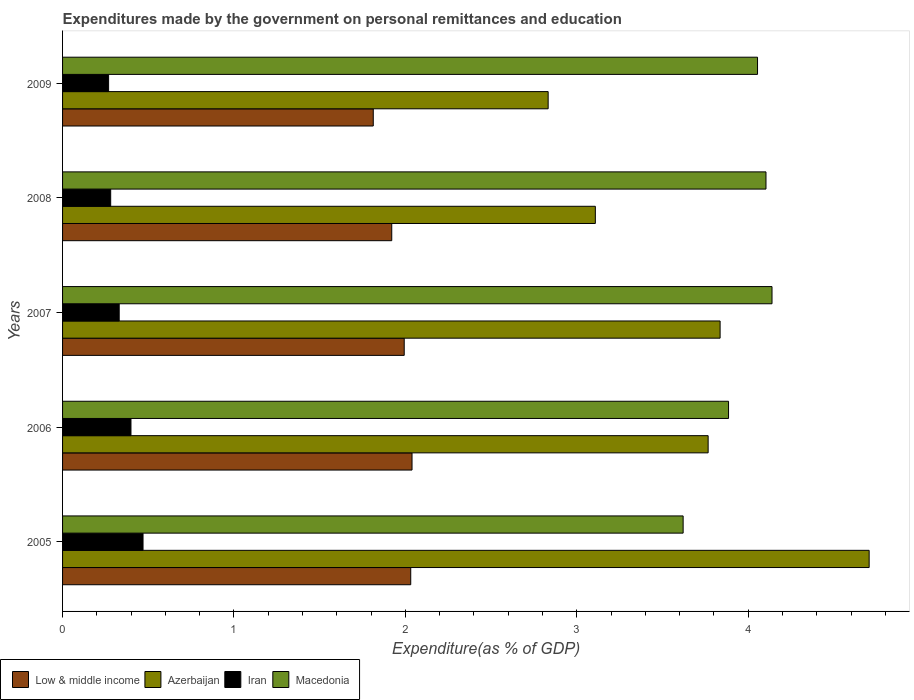How many different coloured bars are there?
Ensure brevity in your answer.  4. Are the number of bars per tick equal to the number of legend labels?
Provide a succinct answer. Yes. How many bars are there on the 5th tick from the top?
Your answer should be very brief. 4. How many bars are there on the 5th tick from the bottom?
Offer a terse response. 4. What is the label of the 3rd group of bars from the top?
Your response must be concise. 2007. What is the expenditures made by the government on personal remittances and education in Low & middle income in 2005?
Ensure brevity in your answer.  2.03. Across all years, what is the maximum expenditures made by the government on personal remittances and education in Iran?
Your response must be concise. 0.47. Across all years, what is the minimum expenditures made by the government on personal remittances and education in Low & middle income?
Ensure brevity in your answer.  1.81. What is the total expenditures made by the government on personal remittances and education in Iran in the graph?
Keep it short and to the point. 1.75. What is the difference between the expenditures made by the government on personal remittances and education in Low & middle income in 2006 and that in 2007?
Keep it short and to the point. 0.05. What is the difference between the expenditures made by the government on personal remittances and education in Low & middle income in 2006 and the expenditures made by the government on personal remittances and education in Iran in 2005?
Your answer should be very brief. 1.57. What is the average expenditures made by the government on personal remittances and education in Low & middle income per year?
Offer a terse response. 1.96. In the year 2007, what is the difference between the expenditures made by the government on personal remittances and education in Iran and expenditures made by the government on personal remittances and education in Azerbaijan?
Ensure brevity in your answer.  -3.51. What is the ratio of the expenditures made by the government on personal remittances and education in Low & middle income in 2006 to that in 2008?
Offer a terse response. 1.06. Is the expenditures made by the government on personal remittances and education in Low & middle income in 2005 less than that in 2006?
Ensure brevity in your answer.  Yes. Is the difference between the expenditures made by the government on personal remittances and education in Iran in 2006 and 2007 greater than the difference between the expenditures made by the government on personal remittances and education in Azerbaijan in 2006 and 2007?
Give a very brief answer. Yes. What is the difference between the highest and the second highest expenditures made by the government on personal remittances and education in Low & middle income?
Give a very brief answer. 0.01. What is the difference between the highest and the lowest expenditures made by the government on personal remittances and education in Azerbaijan?
Provide a short and direct response. 1.87. Is it the case that in every year, the sum of the expenditures made by the government on personal remittances and education in Macedonia and expenditures made by the government on personal remittances and education in Low & middle income is greater than the sum of expenditures made by the government on personal remittances and education in Iran and expenditures made by the government on personal remittances and education in Azerbaijan?
Give a very brief answer. No. What does the 2nd bar from the top in 2008 represents?
Offer a terse response. Iran. What does the 2nd bar from the bottom in 2009 represents?
Offer a very short reply. Azerbaijan. Is it the case that in every year, the sum of the expenditures made by the government on personal remittances and education in Low & middle income and expenditures made by the government on personal remittances and education in Macedonia is greater than the expenditures made by the government on personal remittances and education in Iran?
Your response must be concise. Yes. How many bars are there?
Offer a terse response. 20. Are all the bars in the graph horizontal?
Your response must be concise. Yes. How many years are there in the graph?
Provide a succinct answer. 5. Does the graph contain any zero values?
Offer a very short reply. No. Where does the legend appear in the graph?
Offer a very short reply. Bottom left. How many legend labels are there?
Offer a very short reply. 4. What is the title of the graph?
Offer a very short reply. Expenditures made by the government on personal remittances and education. Does "Kuwait" appear as one of the legend labels in the graph?
Your answer should be very brief. No. What is the label or title of the X-axis?
Keep it short and to the point. Expenditure(as % of GDP). What is the label or title of the Y-axis?
Keep it short and to the point. Years. What is the Expenditure(as % of GDP) in Low & middle income in 2005?
Offer a very short reply. 2.03. What is the Expenditure(as % of GDP) of Azerbaijan in 2005?
Your response must be concise. 4.71. What is the Expenditure(as % of GDP) of Iran in 2005?
Keep it short and to the point. 0.47. What is the Expenditure(as % of GDP) of Macedonia in 2005?
Make the answer very short. 3.62. What is the Expenditure(as % of GDP) in Low & middle income in 2006?
Make the answer very short. 2.04. What is the Expenditure(as % of GDP) of Azerbaijan in 2006?
Provide a short and direct response. 3.77. What is the Expenditure(as % of GDP) in Iran in 2006?
Offer a very short reply. 0.4. What is the Expenditure(as % of GDP) of Macedonia in 2006?
Make the answer very short. 3.88. What is the Expenditure(as % of GDP) of Low & middle income in 2007?
Your answer should be compact. 1.99. What is the Expenditure(as % of GDP) in Azerbaijan in 2007?
Offer a very short reply. 3.84. What is the Expenditure(as % of GDP) in Iran in 2007?
Give a very brief answer. 0.33. What is the Expenditure(as % of GDP) in Macedonia in 2007?
Offer a terse response. 4.14. What is the Expenditure(as % of GDP) in Low & middle income in 2008?
Your answer should be very brief. 1.92. What is the Expenditure(as % of GDP) of Azerbaijan in 2008?
Offer a terse response. 3.11. What is the Expenditure(as % of GDP) of Iran in 2008?
Your answer should be compact. 0.28. What is the Expenditure(as % of GDP) of Macedonia in 2008?
Offer a very short reply. 4.1. What is the Expenditure(as % of GDP) in Low & middle income in 2009?
Provide a short and direct response. 1.81. What is the Expenditure(as % of GDP) of Azerbaijan in 2009?
Provide a succinct answer. 2.83. What is the Expenditure(as % of GDP) in Iran in 2009?
Ensure brevity in your answer.  0.27. What is the Expenditure(as % of GDP) in Macedonia in 2009?
Your answer should be compact. 4.05. Across all years, what is the maximum Expenditure(as % of GDP) in Low & middle income?
Your answer should be compact. 2.04. Across all years, what is the maximum Expenditure(as % of GDP) of Azerbaijan?
Your response must be concise. 4.71. Across all years, what is the maximum Expenditure(as % of GDP) of Iran?
Your response must be concise. 0.47. Across all years, what is the maximum Expenditure(as % of GDP) in Macedonia?
Make the answer very short. 4.14. Across all years, what is the minimum Expenditure(as % of GDP) in Low & middle income?
Offer a very short reply. 1.81. Across all years, what is the minimum Expenditure(as % of GDP) of Azerbaijan?
Ensure brevity in your answer.  2.83. Across all years, what is the minimum Expenditure(as % of GDP) in Iran?
Provide a succinct answer. 0.27. Across all years, what is the minimum Expenditure(as % of GDP) in Macedonia?
Offer a terse response. 3.62. What is the total Expenditure(as % of GDP) of Low & middle income in the graph?
Give a very brief answer. 9.8. What is the total Expenditure(as % of GDP) in Azerbaijan in the graph?
Provide a short and direct response. 18.25. What is the total Expenditure(as % of GDP) of Iran in the graph?
Your response must be concise. 1.75. What is the total Expenditure(as % of GDP) in Macedonia in the graph?
Your answer should be very brief. 19.8. What is the difference between the Expenditure(as % of GDP) of Low & middle income in 2005 and that in 2006?
Keep it short and to the point. -0.01. What is the difference between the Expenditure(as % of GDP) in Azerbaijan in 2005 and that in 2006?
Offer a very short reply. 0.94. What is the difference between the Expenditure(as % of GDP) of Iran in 2005 and that in 2006?
Your answer should be very brief. 0.07. What is the difference between the Expenditure(as % of GDP) of Macedonia in 2005 and that in 2006?
Provide a succinct answer. -0.26. What is the difference between the Expenditure(as % of GDP) of Low & middle income in 2005 and that in 2007?
Give a very brief answer. 0.04. What is the difference between the Expenditure(as % of GDP) of Azerbaijan in 2005 and that in 2007?
Your answer should be compact. 0.87. What is the difference between the Expenditure(as % of GDP) in Iran in 2005 and that in 2007?
Your response must be concise. 0.14. What is the difference between the Expenditure(as % of GDP) of Macedonia in 2005 and that in 2007?
Keep it short and to the point. -0.52. What is the difference between the Expenditure(as % of GDP) in Low & middle income in 2005 and that in 2008?
Your response must be concise. 0.11. What is the difference between the Expenditure(as % of GDP) in Azerbaijan in 2005 and that in 2008?
Offer a very short reply. 1.6. What is the difference between the Expenditure(as % of GDP) in Iran in 2005 and that in 2008?
Give a very brief answer. 0.19. What is the difference between the Expenditure(as % of GDP) of Macedonia in 2005 and that in 2008?
Your answer should be very brief. -0.48. What is the difference between the Expenditure(as % of GDP) in Low & middle income in 2005 and that in 2009?
Keep it short and to the point. 0.22. What is the difference between the Expenditure(as % of GDP) of Azerbaijan in 2005 and that in 2009?
Keep it short and to the point. 1.87. What is the difference between the Expenditure(as % of GDP) of Iran in 2005 and that in 2009?
Keep it short and to the point. 0.2. What is the difference between the Expenditure(as % of GDP) of Macedonia in 2005 and that in 2009?
Ensure brevity in your answer.  -0.43. What is the difference between the Expenditure(as % of GDP) of Low & middle income in 2006 and that in 2007?
Ensure brevity in your answer.  0.05. What is the difference between the Expenditure(as % of GDP) in Azerbaijan in 2006 and that in 2007?
Provide a short and direct response. -0.07. What is the difference between the Expenditure(as % of GDP) in Iran in 2006 and that in 2007?
Your answer should be compact. 0.07. What is the difference between the Expenditure(as % of GDP) in Macedonia in 2006 and that in 2007?
Offer a very short reply. -0.25. What is the difference between the Expenditure(as % of GDP) of Low & middle income in 2006 and that in 2008?
Your answer should be compact. 0.12. What is the difference between the Expenditure(as % of GDP) of Azerbaijan in 2006 and that in 2008?
Provide a short and direct response. 0.66. What is the difference between the Expenditure(as % of GDP) in Iran in 2006 and that in 2008?
Give a very brief answer. 0.12. What is the difference between the Expenditure(as % of GDP) in Macedonia in 2006 and that in 2008?
Provide a succinct answer. -0.22. What is the difference between the Expenditure(as % of GDP) in Low & middle income in 2006 and that in 2009?
Give a very brief answer. 0.23. What is the difference between the Expenditure(as % of GDP) of Azerbaijan in 2006 and that in 2009?
Make the answer very short. 0.93. What is the difference between the Expenditure(as % of GDP) in Iran in 2006 and that in 2009?
Your answer should be very brief. 0.13. What is the difference between the Expenditure(as % of GDP) in Macedonia in 2006 and that in 2009?
Your answer should be very brief. -0.17. What is the difference between the Expenditure(as % of GDP) in Low & middle income in 2007 and that in 2008?
Keep it short and to the point. 0.07. What is the difference between the Expenditure(as % of GDP) of Azerbaijan in 2007 and that in 2008?
Offer a terse response. 0.73. What is the difference between the Expenditure(as % of GDP) of Iran in 2007 and that in 2008?
Your answer should be very brief. 0.05. What is the difference between the Expenditure(as % of GDP) of Macedonia in 2007 and that in 2008?
Your answer should be very brief. 0.04. What is the difference between the Expenditure(as % of GDP) of Low & middle income in 2007 and that in 2009?
Your answer should be very brief. 0.18. What is the difference between the Expenditure(as % of GDP) of Iran in 2007 and that in 2009?
Provide a succinct answer. 0.06. What is the difference between the Expenditure(as % of GDP) in Macedonia in 2007 and that in 2009?
Provide a succinct answer. 0.08. What is the difference between the Expenditure(as % of GDP) of Low & middle income in 2008 and that in 2009?
Your answer should be very brief. 0.11. What is the difference between the Expenditure(as % of GDP) in Azerbaijan in 2008 and that in 2009?
Your answer should be compact. 0.28. What is the difference between the Expenditure(as % of GDP) in Iran in 2008 and that in 2009?
Offer a very short reply. 0.01. What is the difference between the Expenditure(as % of GDP) in Macedonia in 2008 and that in 2009?
Keep it short and to the point. 0.05. What is the difference between the Expenditure(as % of GDP) in Low & middle income in 2005 and the Expenditure(as % of GDP) in Azerbaijan in 2006?
Offer a very short reply. -1.73. What is the difference between the Expenditure(as % of GDP) in Low & middle income in 2005 and the Expenditure(as % of GDP) in Iran in 2006?
Keep it short and to the point. 1.63. What is the difference between the Expenditure(as % of GDP) in Low & middle income in 2005 and the Expenditure(as % of GDP) in Macedonia in 2006?
Provide a short and direct response. -1.85. What is the difference between the Expenditure(as % of GDP) in Azerbaijan in 2005 and the Expenditure(as % of GDP) in Iran in 2006?
Offer a terse response. 4.31. What is the difference between the Expenditure(as % of GDP) in Azerbaijan in 2005 and the Expenditure(as % of GDP) in Macedonia in 2006?
Provide a succinct answer. 0.82. What is the difference between the Expenditure(as % of GDP) in Iran in 2005 and the Expenditure(as % of GDP) in Macedonia in 2006?
Offer a terse response. -3.42. What is the difference between the Expenditure(as % of GDP) in Low & middle income in 2005 and the Expenditure(as % of GDP) in Azerbaijan in 2007?
Keep it short and to the point. -1.8. What is the difference between the Expenditure(as % of GDP) of Low & middle income in 2005 and the Expenditure(as % of GDP) of Iran in 2007?
Give a very brief answer. 1.7. What is the difference between the Expenditure(as % of GDP) of Low & middle income in 2005 and the Expenditure(as % of GDP) of Macedonia in 2007?
Offer a very short reply. -2.11. What is the difference between the Expenditure(as % of GDP) in Azerbaijan in 2005 and the Expenditure(as % of GDP) in Iran in 2007?
Ensure brevity in your answer.  4.37. What is the difference between the Expenditure(as % of GDP) of Azerbaijan in 2005 and the Expenditure(as % of GDP) of Macedonia in 2007?
Keep it short and to the point. 0.57. What is the difference between the Expenditure(as % of GDP) of Iran in 2005 and the Expenditure(as % of GDP) of Macedonia in 2007?
Your response must be concise. -3.67. What is the difference between the Expenditure(as % of GDP) of Low & middle income in 2005 and the Expenditure(as % of GDP) of Azerbaijan in 2008?
Offer a terse response. -1.08. What is the difference between the Expenditure(as % of GDP) of Low & middle income in 2005 and the Expenditure(as % of GDP) of Iran in 2008?
Provide a short and direct response. 1.75. What is the difference between the Expenditure(as % of GDP) of Low & middle income in 2005 and the Expenditure(as % of GDP) of Macedonia in 2008?
Make the answer very short. -2.07. What is the difference between the Expenditure(as % of GDP) of Azerbaijan in 2005 and the Expenditure(as % of GDP) of Iran in 2008?
Give a very brief answer. 4.42. What is the difference between the Expenditure(as % of GDP) in Azerbaijan in 2005 and the Expenditure(as % of GDP) in Macedonia in 2008?
Your answer should be compact. 0.6. What is the difference between the Expenditure(as % of GDP) in Iran in 2005 and the Expenditure(as % of GDP) in Macedonia in 2008?
Make the answer very short. -3.63. What is the difference between the Expenditure(as % of GDP) of Low & middle income in 2005 and the Expenditure(as % of GDP) of Azerbaijan in 2009?
Provide a succinct answer. -0.8. What is the difference between the Expenditure(as % of GDP) in Low & middle income in 2005 and the Expenditure(as % of GDP) in Iran in 2009?
Offer a very short reply. 1.76. What is the difference between the Expenditure(as % of GDP) in Low & middle income in 2005 and the Expenditure(as % of GDP) in Macedonia in 2009?
Provide a succinct answer. -2.02. What is the difference between the Expenditure(as % of GDP) in Azerbaijan in 2005 and the Expenditure(as % of GDP) in Iran in 2009?
Provide a succinct answer. 4.44. What is the difference between the Expenditure(as % of GDP) of Azerbaijan in 2005 and the Expenditure(as % of GDP) of Macedonia in 2009?
Offer a terse response. 0.65. What is the difference between the Expenditure(as % of GDP) in Iran in 2005 and the Expenditure(as % of GDP) in Macedonia in 2009?
Ensure brevity in your answer.  -3.58. What is the difference between the Expenditure(as % of GDP) of Low & middle income in 2006 and the Expenditure(as % of GDP) of Azerbaijan in 2007?
Give a very brief answer. -1.8. What is the difference between the Expenditure(as % of GDP) of Low & middle income in 2006 and the Expenditure(as % of GDP) of Iran in 2007?
Ensure brevity in your answer.  1.71. What is the difference between the Expenditure(as % of GDP) in Azerbaijan in 2006 and the Expenditure(as % of GDP) in Iran in 2007?
Your answer should be compact. 3.44. What is the difference between the Expenditure(as % of GDP) in Azerbaijan in 2006 and the Expenditure(as % of GDP) in Macedonia in 2007?
Provide a succinct answer. -0.37. What is the difference between the Expenditure(as % of GDP) in Iran in 2006 and the Expenditure(as % of GDP) in Macedonia in 2007?
Offer a terse response. -3.74. What is the difference between the Expenditure(as % of GDP) in Low & middle income in 2006 and the Expenditure(as % of GDP) in Azerbaijan in 2008?
Offer a very short reply. -1.07. What is the difference between the Expenditure(as % of GDP) in Low & middle income in 2006 and the Expenditure(as % of GDP) in Iran in 2008?
Your answer should be compact. 1.76. What is the difference between the Expenditure(as % of GDP) of Low & middle income in 2006 and the Expenditure(as % of GDP) of Macedonia in 2008?
Your answer should be very brief. -2.06. What is the difference between the Expenditure(as % of GDP) of Azerbaijan in 2006 and the Expenditure(as % of GDP) of Iran in 2008?
Offer a terse response. 3.49. What is the difference between the Expenditure(as % of GDP) of Azerbaijan in 2006 and the Expenditure(as % of GDP) of Macedonia in 2008?
Give a very brief answer. -0.34. What is the difference between the Expenditure(as % of GDP) in Iran in 2006 and the Expenditure(as % of GDP) in Macedonia in 2008?
Offer a terse response. -3.7. What is the difference between the Expenditure(as % of GDP) of Low & middle income in 2006 and the Expenditure(as % of GDP) of Azerbaijan in 2009?
Provide a succinct answer. -0.79. What is the difference between the Expenditure(as % of GDP) in Low & middle income in 2006 and the Expenditure(as % of GDP) in Iran in 2009?
Ensure brevity in your answer.  1.77. What is the difference between the Expenditure(as % of GDP) of Low & middle income in 2006 and the Expenditure(as % of GDP) of Macedonia in 2009?
Your answer should be very brief. -2.02. What is the difference between the Expenditure(as % of GDP) of Azerbaijan in 2006 and the Expenditure(as % of GDP) of Iran in 2009?
Offer a terse response. 3.5. What is the difference between the Expenditure(as % of GDP) in Azerbaijan in 2006 and the Expenditure(as % of GDP) in Macedonia in 2009?
Keep it short and to the point. -0.29. What is the difference between the Expenditure(as % of GDP) in Iran in 2006 and the Expenditure(as % of GDP) in Macedonia in 2009?
Provide a short and direct response. -3.66. What is the difference between the Expenditure(as % of GDP) in Low & middle income in 2007 and the Expenditure(as % of GDP) in Azerbaijan in 2008?
Your response must be concise. -1.11. What is the difference between the Expenditure(as % of GDP) in Low & middle income in 2007 and the Expenditure(as % of GDP) in Iran in 2008?
Ensure brevity in your answer.  1.71. What is the difference between the Expenditure(as % of GDP) of Low & middle income in 2007 and the Expenditure(as % of GDP) of Macedonia in 2008?
Offer a very short reply. -2.11. What is the difference between the Expenditure(as % of GDP) of Azerbaijan in 2007 and the Expenditure(as % of GDP) of Iran in 2008?
Give a very brief answer. 3.56. What is the difference between the Expenditure(as % of GDP) in Azerbaijan in 2007 and the Expenditure(as % of GDP) in Macedonia in 2008?
Your response must be concise. -0.27. What is the difference between the Expenditure(as % of GDP) in Iran in 2007 and the Expenditure(as % of GDP) in Macedonia in 2008?
Keep it short and to the point. -3.77. What is the difference between the Expenditure(as % of GDP) of Low & middle income in 2007 and the Expenditure(as % of GDP) of Azerbaijan in 2009?
Provide a succinct answer. -0.84. What is the difference between the Expenditure(as % of GDP) in Low & middle income in 2007 and the Expenditure(as % of GDP) in Iran in 2009?
Ensure brevity in your answer.  1.72. What is the difference between the Expenditure(as % of GDP) in Low & middle income in 2007 and the Expenditure(as % of GDP) in Macedonia in 2009?
Make the answer very short. -2.06. What is the difference between the Expenditure(as % of GDP) in Azerbaijan in 2007 and the Expenditure(as % of GDP) in Iran in 2009?
Provide a short and direct response. 3.57. What is the difference between the Expenditure(as % of GDP) in Azerbaijan in 2007 and the Expenditure(as % of GDP) in Macedonia in 2009?
Your answer should be compact. -0.22. What is the difference between the Expenditure(as % of GDP) in Iran in 2007 and the Expenditure(as % of GDP) in Macedonia in 2009?
Keep it short and to the point. -3.72. What is the difference between the Expenditure(as % of GDP) in Low & middle income in 2008 and the Expenditure(as % of GDP) in Azerbaijan in 2009?
Give a very brief answer. -0.91. What is the difference between the Expenditure(as % of GDP) in Low & middle income in 2008 and the Expenditure(as % of GDP) in Iran in 2009?
Provide a short and direct response. 1.65. What is the difference between the Expenditure(as % of GDP) of Low & middle income in 2008 and the Expenditure(as % of GDP) of Macedonia in 2009?
Ensure brevity in your answer.  -2.13. What is the difference between the Expenditure(as % of GDP) in Azerbaijan in 2008 and the Expenditure(as % of GDP) in Iran in 2009?
Provide a short and direct response. 2.84. What is the difference between the Expenditure(as % of GDP) in Azerbaijan in 2008 and the Expenditure(as % of GDP) in Macedonia in 2009?
Your answer should be very brief. -0.95. What is the difference between the Expenditure(as % of GDP) in Iran in 2008 and the Expenditure(as % of GDP) in Macedonia in 2009?
Provide a succinct answer. -3.77. What is the average Expenditure(as % of GDP) in Low & middle income per year?
Offer a terse response. 1.96. What is the average Expenditure(as % of GDP) in Azerbaijan per year?
Your answer should be compact. 3.65. What is the average Expenditure(as % of GDP) of Iran per year?
Ensure brevity in your answer.  0.35. What is the average Expenditure(as % of GDP) in Macedonia per year?
Your response must be concise. 3.96. In the year 2005, what is the difference between the Expenditure(as % of GDP) in Low & middle income and Expenditure(as % of GDP) in Azerbaijan?
Your response must be concise. -2.67. In the year 2005, what is the difference between the Expenditure(as % of GDP) in Low & middle income and Expenditure(as % of GDP) in Iran?
Provide a succinct answer. 1.56. In the year 2005, what is the difference between the Expenditure(as % of GDP) in Low & middle income and Expenditure(as % of GDP) in Macedonia?
Ensure brevity in your answer.  -1.59. In the year 2005, what is the difference between the Expenditure(as % of GDP) in Azerbaijan and Expenditure(as % of GDP) in Iran?
Ensure brevity in your answer.  4.24. In the year 2005, what is the difference between the Expenditure(as % of GDP) in Azerbaijan and Expenditure(as % of GDP) in Macedonia?
Make the answer very short. 1.09. In the year 2005, what is the difference between the Expenditure(as % of GDP) in Iran and Expenditure(as % of GDP) in Macedonia?
Give a very brief answer. -3.15. In the year 2006, what is the difference between the Expenditure(as % of GDP) of Low & middle income and Expenditure(as % of GDP) of Azerbaijan?
Ensure brevity in your answer.  -1.73. In the year 2006, what is the difference between the Expenditure(as % of GDP) of Low & middle income and Expenditure(as % of GDP) of Iran?
Offer a terse response. 1.64. In the year 2006, what is the difference between the Expenditure(as % of GDP) of Low & middle income and Expenditure(as % of GDP) of Macedonia?
Offer a terse response. -1.85. In the year 2006, what is the difference between the Expenditure(as % of GDP) in Azerbaijan and Expenditure(as % of GDP) in Iran?
Your answer should be very brief. 3.37. In the year 2006, what is the difference between the Expenditure(as % of GDP) in Azerbaijan and Expenditure(as % of GDP) in Macedonia?
Give a very brief answer. -0.12. In the year 2006, what is the difference between the Expenditure(as % of GDP) in Iran and Expenditure(as % of GDP) in Macedonia?
Your answer should be very brief. -3.49. In the year 2007, what is the difference between the Expenditure(as % of GDP) in Low & middle income and Expenditure(as % of GDP) in Azerbaijan?
Your response must be concise. -1.84. In the year 2007, what is the difference between the Expenditure(as % of GDP) of Low & middle income and Expenditure(as % of GDP) of Iran?
Keep it short and to the point. 1.66. In the year 2007, what is the difference between the Expenditure(as % of GDP) of Low & middle income and Expenditure(as % of GDP) of Macedonia?
Give a very brief answer. -2.15. In the year 2007, what is the difference between the Expenditure(as % of GDP) in Azerbaijan and Expenditure(as % of GDP) in Iran?
Keep it short and to the point. 3.51. In the year 2007, what is the difference between the Expenditure(as % of GDP) of Azerbaijan and Expenditure(as % of GDP) of Macedonia?
Provide a short and direct response. -0.3. In the year 2007, what is the difference between the Expenditure(as % of GDP) in Iran and Expenditure(as % of GDP) in Macedonia?
Your response must be concise. -3.81. In the year 2008, what is the difference between the Expenditure(as % of GDP) of Low & middle income and Expenditure(as % of GDP) of Azerbaijan?
Your response must be concise. -1.19. In the year 2008, what is the difference between the Expenditure(as % of GDP) in Low & middle income and Expenditure(as % of GDP) in Iran?
Ensure brevity in your answer.  1.64. In the year 2008, what is the difference between the Expenditure(as % of GDP) of Low & middle income and Expenditure(as % of GDP) of Macedonia?
Give a very brief answer. -2.18. In the year 2008, what is the difference between the Expenditure(as % of GDP) of Azerbaijan and Expenditure(as % of GDP) of Iran?
Make the answer very short. 2.83. In the year 2008, what is the difference between the Expenditure(as % of GDP) in Azerbaijan and Expenditure(as % of GDP) in Macedonia?
Your answer should be very brief. -1. In the year 2008, what is the difference between the Expenditure(as % of GDP) of Iran and Expenditure(as % of GDP) of Macedonia?
Provide a short and direct response. -3.82. In the year 2009, what is the difference between the Expenditure(as % of GDP) of Low & middle income and Expenditure(as % of GDP) of Azerbaijan?
Make the answer very short. -1.02. In the year 2009, what is the difference between the Expenditure(as % of GDP) in Low & middle income and Expenditure(as % of GDP) in Iran?
Your answer should be compact. 1.54. In the year 2009, what is the difference between the Expenditure(as % of GDP) in Low & middle income and Expenditure(as % of GDP) in Macedonia?
Provide a short and direct response. -2.24. In the year 2009, what is the difference between the Expenditure(as % of GDP) of Azerbaijan and Expenditure(as % of GDP) of Iran?
Keep it short and to the point. 2.56. In the year 2009, what is the difference between the Expenditure(as % of GDP) of Azerbaijan and Expenditure(as % of GDP) of Macedonia?
Your answer should be very brief. -1.22. In the year 2009, what is the difference between the Expenditure(as % of GDP) of Iran and Expenditure(as % of GDP) of Macedonia?
Keep it short and to the point. -3.79. What is the ratio of the Expenditure(as % of GDP) in Azerbaijan in 2005 to that in 2006?
Provide a succinct answer. 1.25. What is the ratio of the Expenditure(as % of GDP) in Iran in 2005 to that in 2006?
Your answer should be very brief. 1.18. What is the ratio of the Expenditure(as % of GDP) in Macedonia in 2005 to that in 2006?
Make the answer very short. 0.93. What is the ratio of the Expenditure(as % of GDP) of Low & middle income in 2005 to that in 2007?
Your response must be concise. 1.02. What is the ratio of the Expenditure(as % of GDP) of Azerbaijan in 2005 to that in 2007?
Keep it short and to the point. 1.23. What is the ratio of the Expenditure(as % of GDP) in Iran in 2005 to that in 2007?
Your answer should be compact. 1.42. What is the ratio of the Expenditure(as % of GDP) in Macedonia in 2005 to that in 2007?
Offer a terse response. 0.87. What is the ratio of the Expenditure(as % of GDP) in Low & middle income in 2005 to that in 2008?
Give a very brief answer. 1.06. What is the ratio of the Expenditure(as % of GDP) in Azerbaijan in 2005 to that in 2008?
Provide a succinct answer. 1.51. What is the ratio of the Expenditure(as % of GDP) in Iran in 2005 to that in 2008?
Give a very brief answer. 1.67. What is the ratio of the Expenditure(as % of GDP) in Macedonia in 2005 to that in 2008?
Your response must be concise. 0.88. What is the ratio of the Expenditure(as % of GDP) in Low & middle income in 2005 to that in 2009?
Make the answer very short. 1.12. What is the ratio of the Expenditure(as % of GDP) of Azerbaijan in 2005 to that in 2009?
Your response must be concise. 1.66. What is the ratio of the Expenditure(as % of GDP) in Iran in 2005 to that in 2009?
Keep it short and to the point. 1.75. What is the ratio of the Expenditure(as % of GDP) of Macedonia in 2005 to that in 2009?
Give a very brief answer. 0.89. What is the ratio of the Expenditure(as % of GDP) of Low & middle income in 2006 to that in 2007?
Provide a succinct answer. 1.02. What is the ratio of the Expenditure(as % of GDP) of Azerbaijan in 2006 to that in 2007?
Keep it short and to the point. 0.98. What is the ratio of the Expenditure(as % of GDP) in Iran in 2006 to that in 2007?
Make the answer very short. 1.21. What is the ratio of the Expenditure(as % of GDP) in Macedonia in 2006 to that in 2007?
Offer a very short reply. 0.94. What is the ratio of the Expenditure(as % of GDP) in Low & middle income in 2006 to that in 2008?
Make the answer very short. 1.06. What is the ratio of the Expenditure(as % of GDP) of Azerbaijan in 2006 to that in 2008?
Make the answer very short. 1.21. What is the ratio of the Expenditure(as % of GDP) of Iran in 2006 to that in 2008?
Offer a terse response. 1.42. What is the ratio of the Expenditure(as % of GDP) of Macedonia in 2006 to that in 2008?
Give a very brief answer. 0.95. What is the ratio of the Expenditure(as % of GDP) of Low & middle income in 2006 to that in 2009?
Provide a succinct answer. 1.12. What is the ratio of the Expenditure(as % of GDP) in Azerbaijan in 2006 to that in 2009?
Your response must be concise. 1.33. What is the ratio of the Expenditure(as % of GDP) of Iran in 2006 to that in 2009?
Offer a terse response. 1.49. What is the ratio of the Expenditure(as % of GDP) in Macedonia in 2006 to that in 2009?
Offer a terse response. 0.96. What is the ratio of the Expenditure(as % of GDP) of Low & middle income in 2007 to that in 2008?
Your response must be concise. 1.04. What is the ratio of the Expenditure(as % of GDP) in Azerbaijan in 2007 to that in 2008?
Offer a terse response. 1.23. What is the ratio of the Expenditure(as % of GDP) of Iran in 2007 to that in 2008?
Keep it short and to the point. 1.18. What is the ratio of the Expenditure(as % of GDP) in Macedonia in 2007 to that in 2008?
Ensure brevity in your answer.  1.01. What is the ratio of the Expenditure(as % of GDP) of Low & middle income in 2007 to that in 2009?
Provide a short and direct response. 1.1. What is the ratio of the Expenditure(as % of GDP) in Azerbaijan in 2007 to that in 2009?
Give a very brief answer. 1.35. What is the ratio of the Expenditure(as % of GDP) of Iran in 2007 to that in 2009?
Your response must be concise. 1.23. What is the ratio of the Expenditure(as % of GDP) of Macedonia in 2007 to that in 2009?
Keep it short and to the point. 1.02. What is the ratio of the Expenditure(as % of GDP) in Low & middle income in 2008 to that in 2009?
Keep it short and to the point. 1.06. What is the ratio of the Expenditure(as % of GDP) in Azerbaijan in 2008 to that in 2009?
Make the answer very short. 1.1. What is the ratio of the Expenditure(as % of GDP) of Iran in 2008 to that in 2009?
Your answer should be compact. 1.04. What is the ratio of the Expenditure(as % of GDP) in Macedonia in 2008 to that in 2009?
Your answer should be compact. 1.01. What is the difference between the highest and the second highest Expenditure(as % of GDP) of Low & middle income?
Offer a terse response. 0.01. What is the difference between the highest and the second highest Expenditure(as % of GDP) in Azerbaijan?
Give a very brief answer. 0.87. What is the difference between the highest and the second highest Expenditure(as % of GDP) in Iran?
Your answer should be very brief. 0.07. What is the difference between the highest and the second highest Expenditure(as % of GDP) in Macedonia?
Give a very brief answer. 0.04. What is the difference between the highest and the lowest Expenditure(as % of GDP) in Low & middle income?
Provide a short and direct response. 0.23. What is the difference between the highest and the lowest Expenditure(as % of GDP) in Azerbaijan?
Your answer should be compact. 1.87. What is the difference between the highest and the lowest Expenditure(as % of GDP) in Iran?
Your answer should be very brief. 0.2. What is the difference between the highest and the lowest Expenditure(as % of GDP) in Macedonia?
Give a very brief answer. 0.52. 